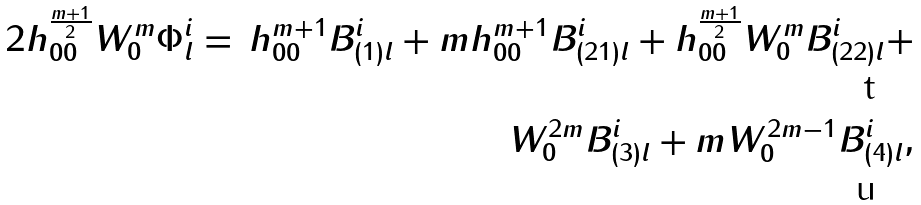Convert formula to latex. <formula><loc_0><loc_0><loc_500><loc_500>2 h _ { 0 0 } ^ { \frac { m + 1 } { 2 } } W _ { 0 } ^ { m } \Phi ^ { i } _ { \| l } & = & h _ { 0 0 } ^ { m + 1 } B ^ { i } _ { ( 1 ) \| l } + m h _ { 0 0 } ^ { m + 1 } B ^ { i } _ { ( 2 1 ) l } + h _ { 0 0 } ^ { \frac { m + 1 } { 2 } } W _ { 0 } ^ { m } B ^ { i } _ { ( 2 2 ) l } + \\ & & W _ { 0 } ^ { 2 m } B ^ { i } _ { ( 3 ) l } + m W _ { 0 } ^ { 2 m - 1 } B ^ { i } _ { ( 4 ) l } ,</formula> 